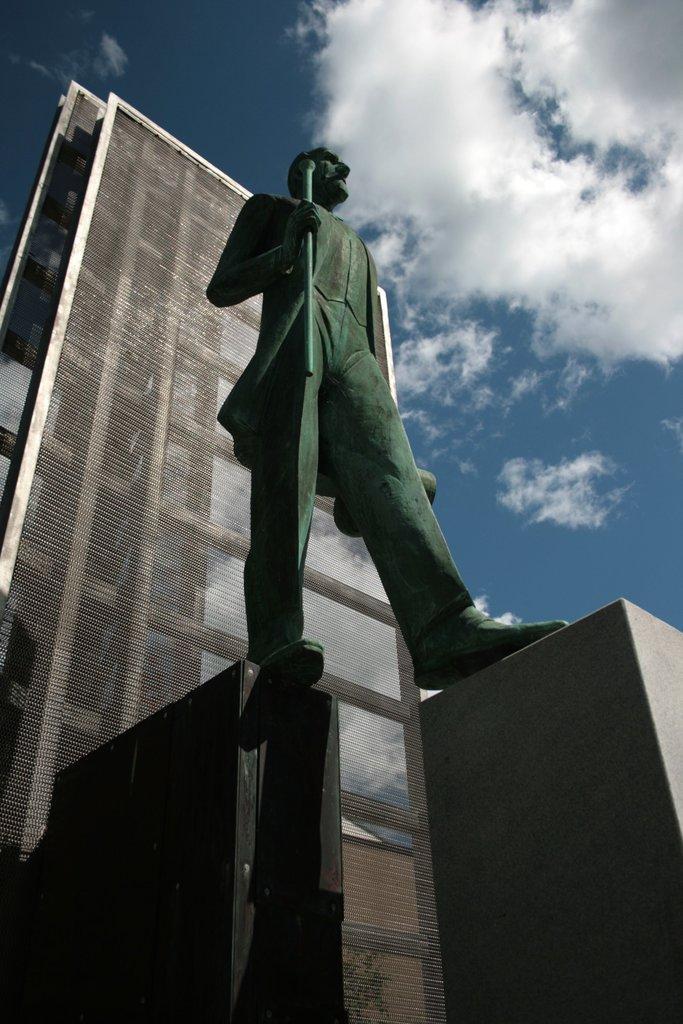Could you give a brief overview of what you see in this image? In this picture I can see there is a statue of a person standing on a rock and there is a weapon and in the backdrop there is a wall in the backdrop and the sky is clear. 